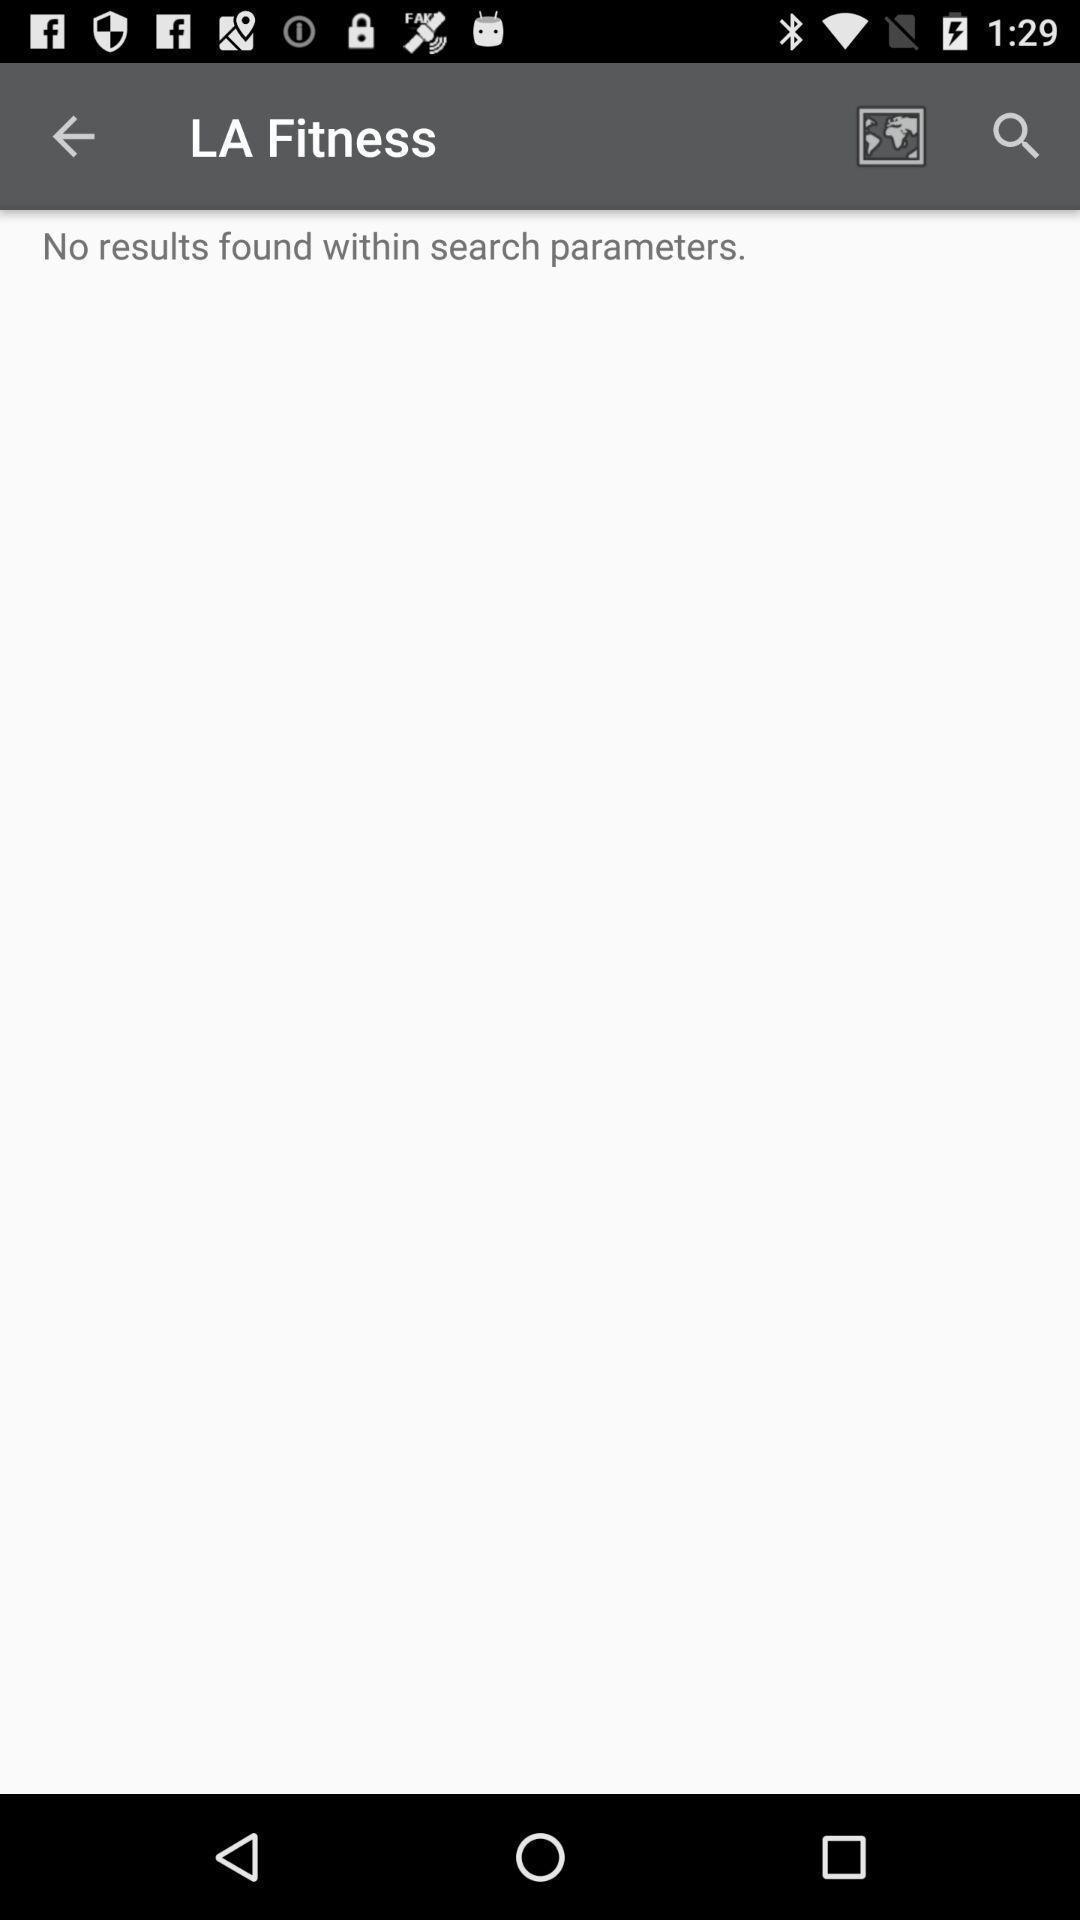Explain the elements present in this screenshot. Search page showing no results found. 